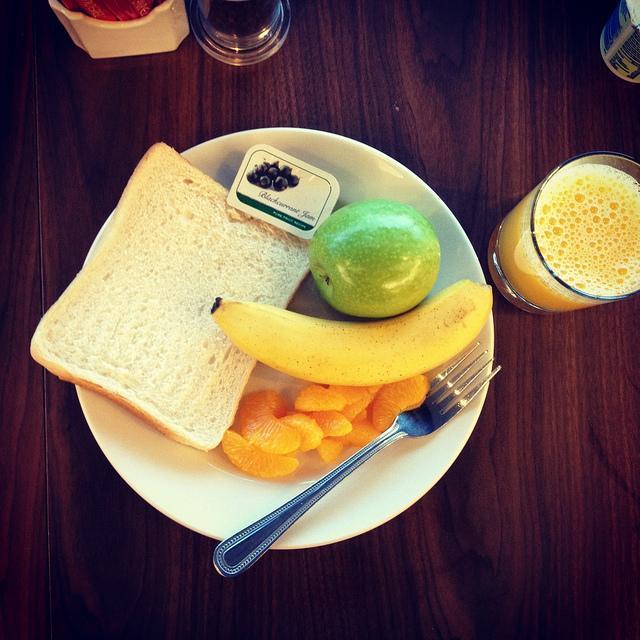Does the caption "The sandwich is on top of the banana." correctly depict the image?
Answer yes or no. No. Verify the accuracy of this image caption: "The banana is at the right side of the sandwich.".
Answer yes or no. Yes. 